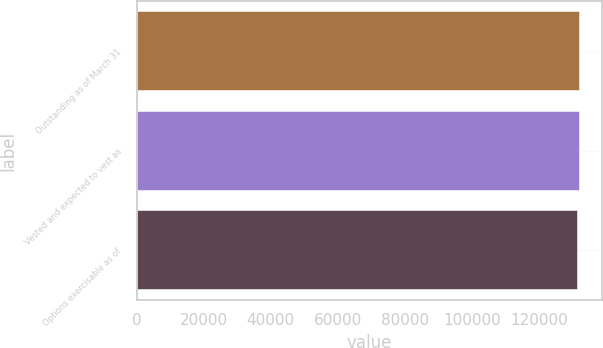Convert chart. <chart><loc_0><loc_0><loc_500><loc_500><bar_chart><fcel>Outstanding as of March 31<fcel>Vested and expected to vest as<fcel>Options exercisable as of<nl><fcel>132279<fcel>132216<fcel>131585<nl></chart> 